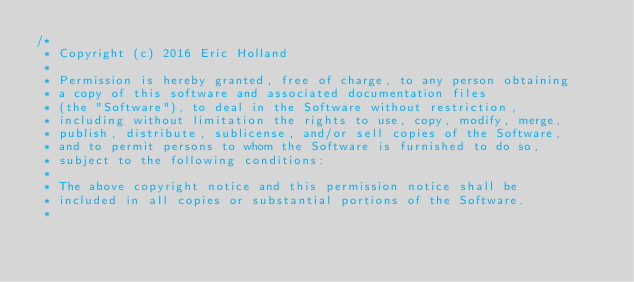<code> <loc_0><loc_0><loc_500><loc_500><_C_>/*
 * Copyright (c) 2016 Eric Holland
 *
 * Permission is hereby granted, free of charge, to any person obtaining
 * a copy of this software and associated documentation files
 * (the "Software"), to deal in the Software without restriction,
 * including without limitation the rights to use, copy, modify, merge,
 * publish, distribute, sublicense, and/or sell copies of the Software,
 * and to permit persons to whom the Software is furnished to do so,
 * subject to the following conditions:
 *
 * The above copyright notice and this permission notice shall be
 * included in all copies or substantial portions of the Software.
 *</code> 